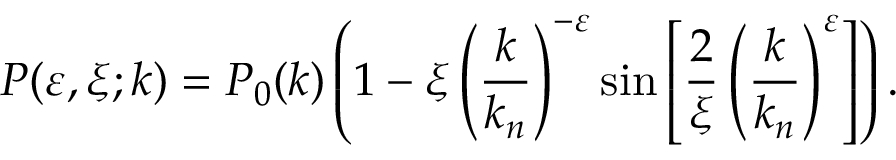<formula> <loc_0><loc_0><loc_500><loc_500>P ( \varepsilon , \xi ; k ) = P _ { 0 } ( k ) \left ( 1 - \xi \left ( { \frac { k } { k _ { n } } } \right ) ^ { - \varepsilon } \sin \left [ { \frac { 2 } { \xi } } \left ( { \frac { k } { k _ { n } } } \right ) ^ { \varepsilon } \right ] \right ) .</formula> 